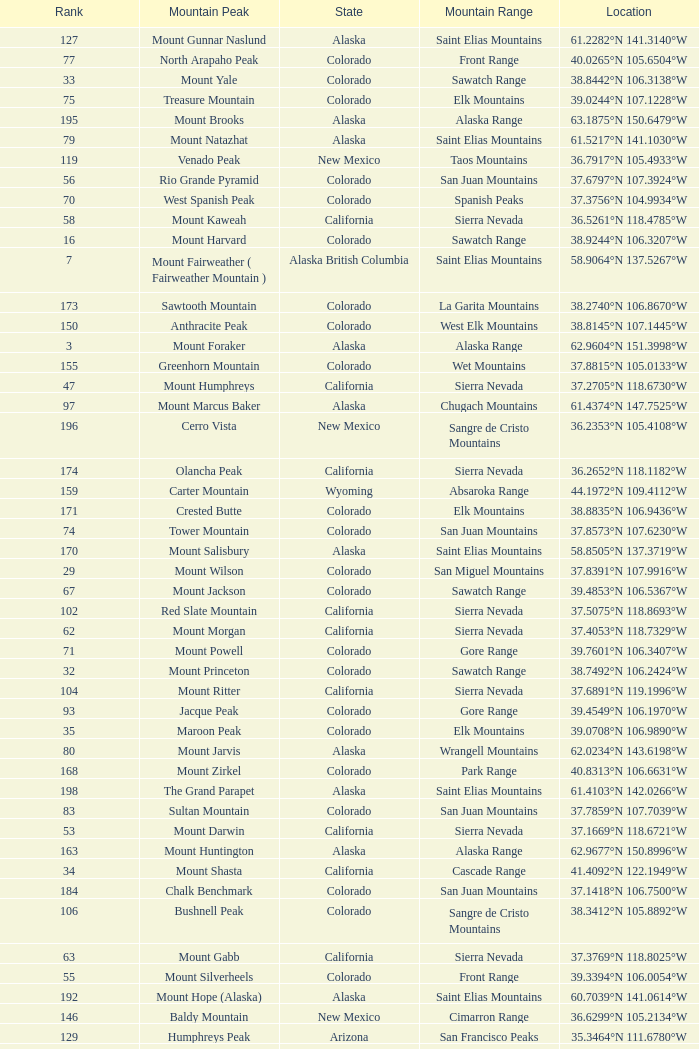What is the mountain peak when the location is 37.5775°n 105.4856°w? Blanca Peak. 